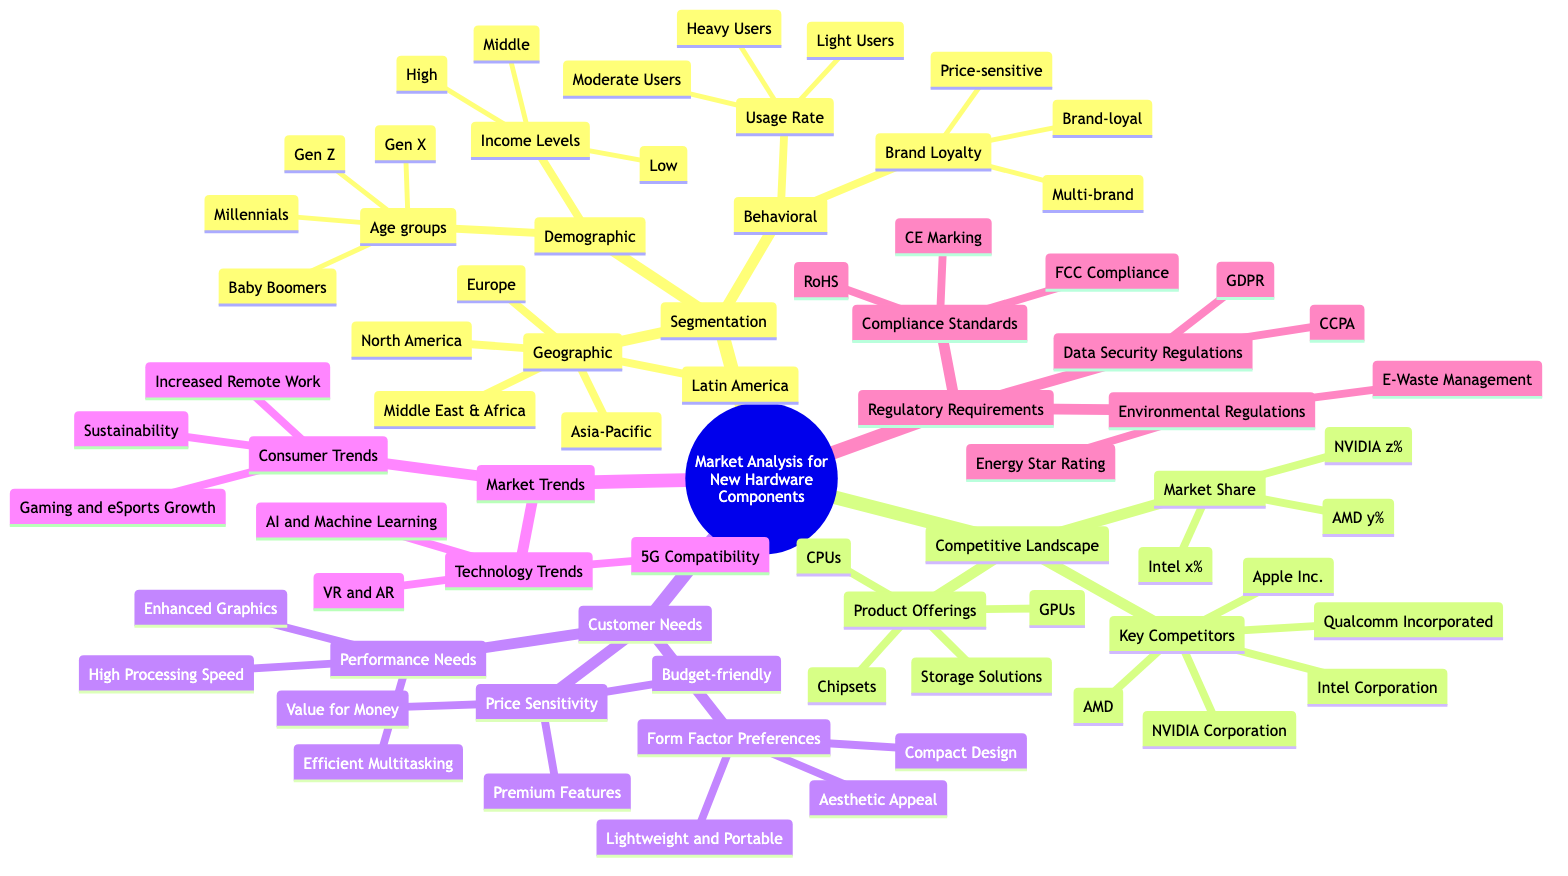What are the four age groups mentioned in the demographic segmentation? The demographic segmentation node has a sub-node related to age groups, which lists Gen Z, Millennials, Gen X, and Baby Boomers as the four specified groups.
Answer: Gen Z, Millennials, Gen X, Baby Boomers How many key competitors are listed under the competitive landscape? The key competitors node contains five different companies: Intel Corporation, AMD, NVIDIA Corporation, Qualcomm Incorporated, and Apple Inc., making a total of five key competitors.
Answer: 5 Which technology trend emphasizes augmented reality? The market trends section includes technology trends, and one of them is specified as VR and AR, highlighting the emphasis on augmented reality.
Answer: VR and AR What are the three performance needs identified for customer needs? The customer needs section specifies performance needs, which are listed as high processing speed, efficient multitasking, and enhanced graphics.
Answer: High Processing Speed, Efficient Multitasking, Enhanced Graphics Which compliance standard is related to hazardous substances? Under regulatory requirements, the compliance standards sub-node mentions RoHS, which stands for Restriction of Hazardous Substances, indicating its relevance to hazardous substances.
Answer: RoHS What is the total number of segments in the market analysis? The main nodes under "Market Analysis for New Hardware Components" include Segmentation, Competitive Landscape, Customer Needs, Market Trends, and Regulatory Requirements. This totals five segments in the market analysis.
Answer: 5 What type of users are categorized as heavy users? The behavioral segmentation mentions usage rate as a category, where one of the defined segments is heavy users, indicating their classification based on usage.
Answer: Heavy Users Which two main consumer trends are noted in the market trends section? In the consumer trends sub-node under market trends, two listed trends are increased remote work and gaming and eSports growth, reflecting current consumer behaviors.
Answer: Increased Remote Work, Gaming and eSports Growth What are the environmental regulations mentioned in the regulatory requirements? Within the regulatory requirements, a specific node outlines environmental regulations that include e-waste management and energy star rating, illustrating compliance requirements for sustainability.
Answer: E-Waste Management, Energy Star Rating 